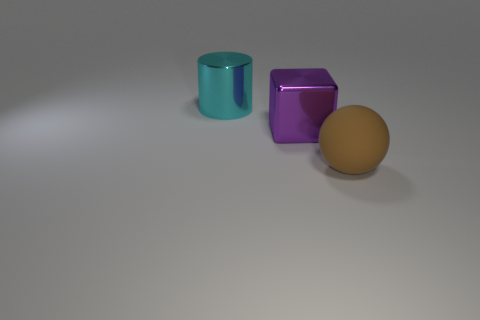Add 2 big rubber objects. How many objects exist? 5 Subtract all spheres. How many objects are left? 2 Subtract all large green metallic spheres. Subtract all big brown balls. How many objects are left? 2 Add 2 cyan metal cylinders. How many cyan metal cylinders are left? 3 Add 2 large brown things. How many large brown things exist? 3 Subtract 0 yellow cylinders. How many objects are left? 3 